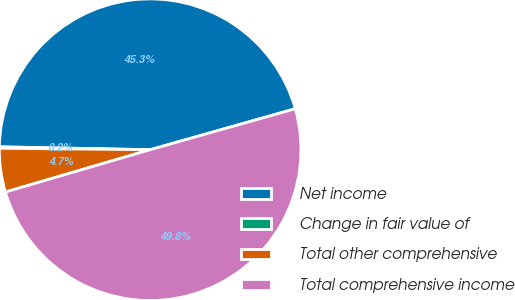<chart> <loc_0><loc_0><loc_500><loc_500><pie_chart><fcel>Net income<fcel>Change in fair value of<fcel>Total other comprehensive<fcel>Total comprehensive income<nl><fcel>45.32%<fcel>0.15%<fcel>4.68%<fcel>49.85%<nl></chart> 